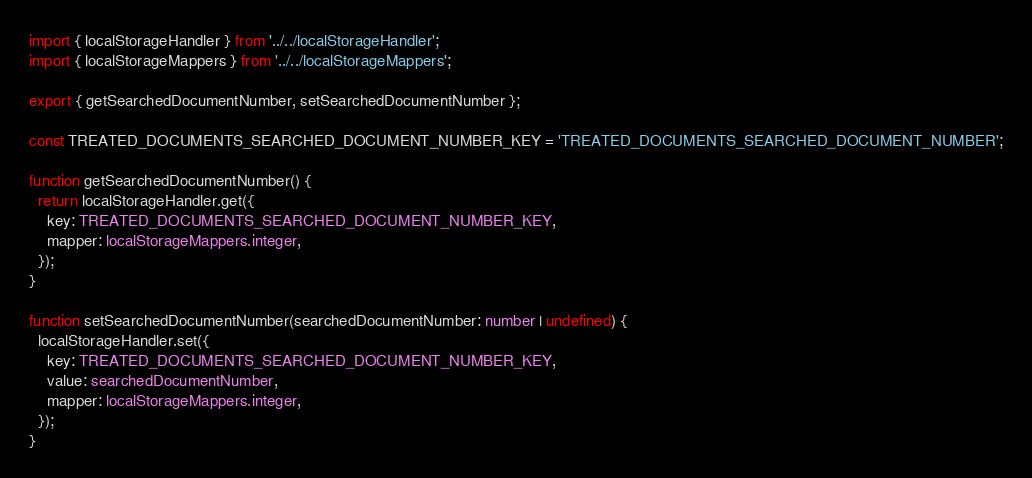<code> <loc_0><loc_0><loc_500><loc_500><_TypeScript_>import { localStorageHandler } from '../../localStorageHandler';
import { localStorageMappers } from '../../localStorageMappers';

export { getSearchedDocumentNumber, setSearchedDocumentNumber };

const TREATED_DOCUMENTS_SEARCHED_DOCUMENT_NUMBER_KEY = 'TREATED_DOCUMENTS_SEARCHED_DOCUMENT_NUMBER';

function getSearchedDocumentNumber() {
  return localStorageHandler.get({
    key: TREATED_DOCUMENTS_SEARCHED_DOCUMENT_NUMBER_KEY,
    mapper: localStorageMappers.integer,
  });
}

function setSearchedDocumentNumber(searchedDocumentNumber: number | undefined) {
  localStorageHandler.set({
    key: TREATED_DOCUMENTS_SEARCHED_DOCUMENT_NUMBER_KEY,
    value: searchedDocumentNumber,
    mapper: localStorageMappers.integer,
  });
}
</code> 